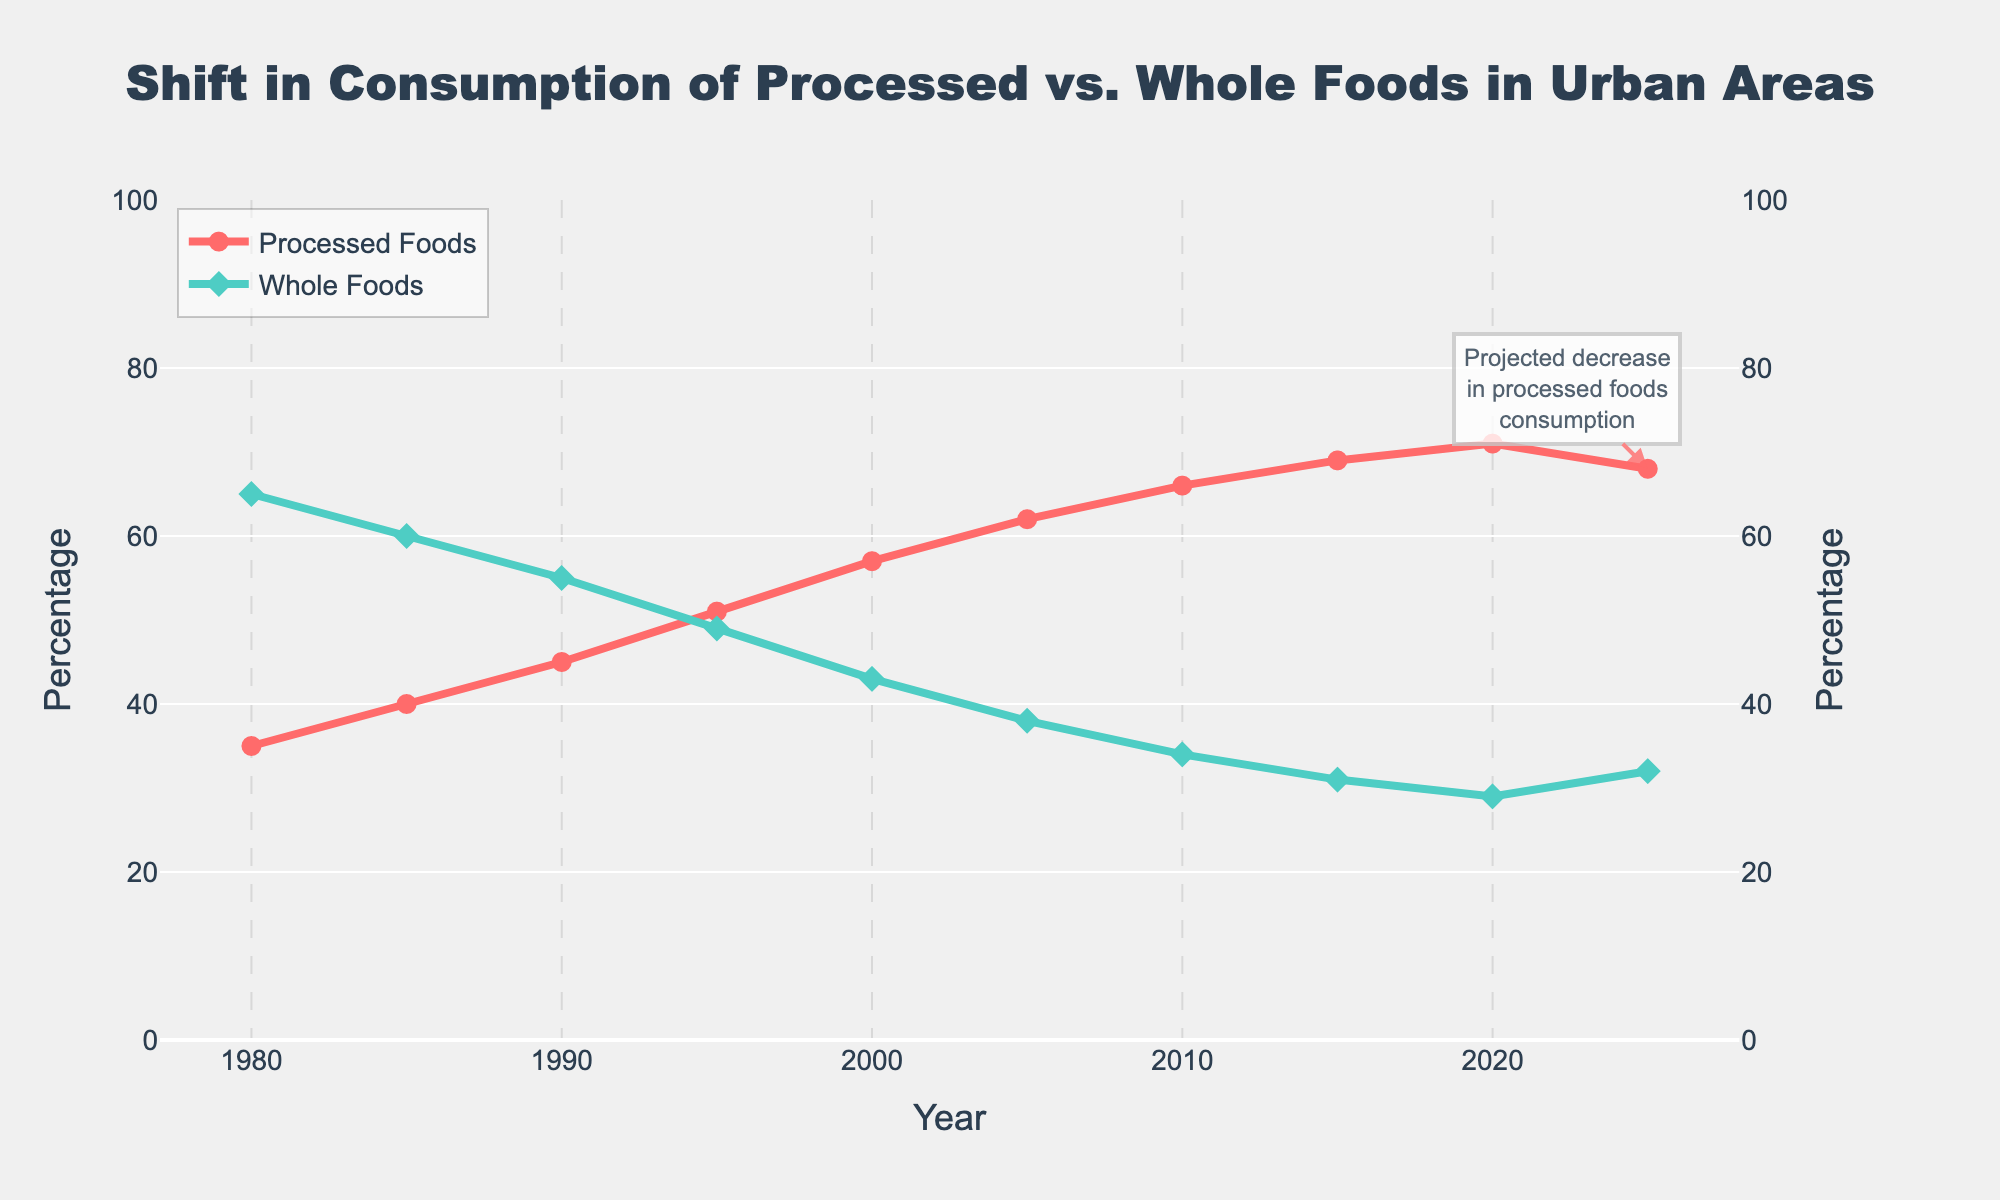Which year saw the highest percentage of processed foods consumption? To find the year with the highest percentage of processed foods consumption, look at the line labeled "Processed Foods" and identify the peak point. The peak occurs in the year 2020 at 71%.
Answer: 2020 How much did the percentage of whole foods consumption decrease from 1980 to 2020? To calculate the decrease, subtract the percentage of whole foods in 2020 from the percentage in 1980. This is 65% - 29% = 36%.
Answer: 36% Between which years did processed foods consumption see the largest increase? To determine the largest increase, look at the differences between the data points across the years on the "Processed Foods" line. The biggest jump is between 1995 (51%) and 2000 (57%), which is an increase of 6%.
Answer: 1995 and 2000 Is there a year where the percentage of whole foods and processed foods were exactly equal? Locate the point where the two lines intersect. The two lines intersect around 1995, when both percentages are close to 49% (Whole Foods) and 51% (Processed Foods).
Answer: No What is the overall trend for whole foods consumption from 1980 to 2025? Observe the line representing whole foods consumption and identify the general direction from 1980 to 2025. The trend shows a consistent decline from 65% in 1980 to 32% in 2025.
Answer: Decline How much did the consumption of processed foods change from 2015 to 2025? To find the change, subtract the percentage of processed foods in 2025 from the percentage in 2015. This is 68% - 69% = -1%. Therefore, there was a 1% decrease.
Answer: 1% decrease Which year shows the sharpest decline in whole foods consumption? To determine the sharpest decline, compare the differences in percentages year by year on the "Whole Foods" line. The steepest drop is between 1990 (55%) and 1995 (49%), a decrease of 6%.
Answer: 1990 to 1995 What happens to the percentage of whole foods consumption after 2020? Does it increase or decrease? After identifying the data point for 2020, observe the trend moving towards 2025. Whole foods consumption increases from 29% to 32%.
Answer: Increase What is the average percentage of processed foods consumption from 1980 to 2020? Calculate the average by adding all the percentages of processed foods from 1980 to 2020 and dividing by the number of years (9). (35+40+45+51+57+62+66+69+71) / 9 = 55.1%.
Answer: 55.1% How did the consumption of whole foods in 2025 compare to that in 2000? To compare, subtract the percentage of whole foods in 2025 from that in 2000. This is 43% - 32% = 11%. Therefore, whole foods decreased by 11%.
Answer: Decrease by 11% 